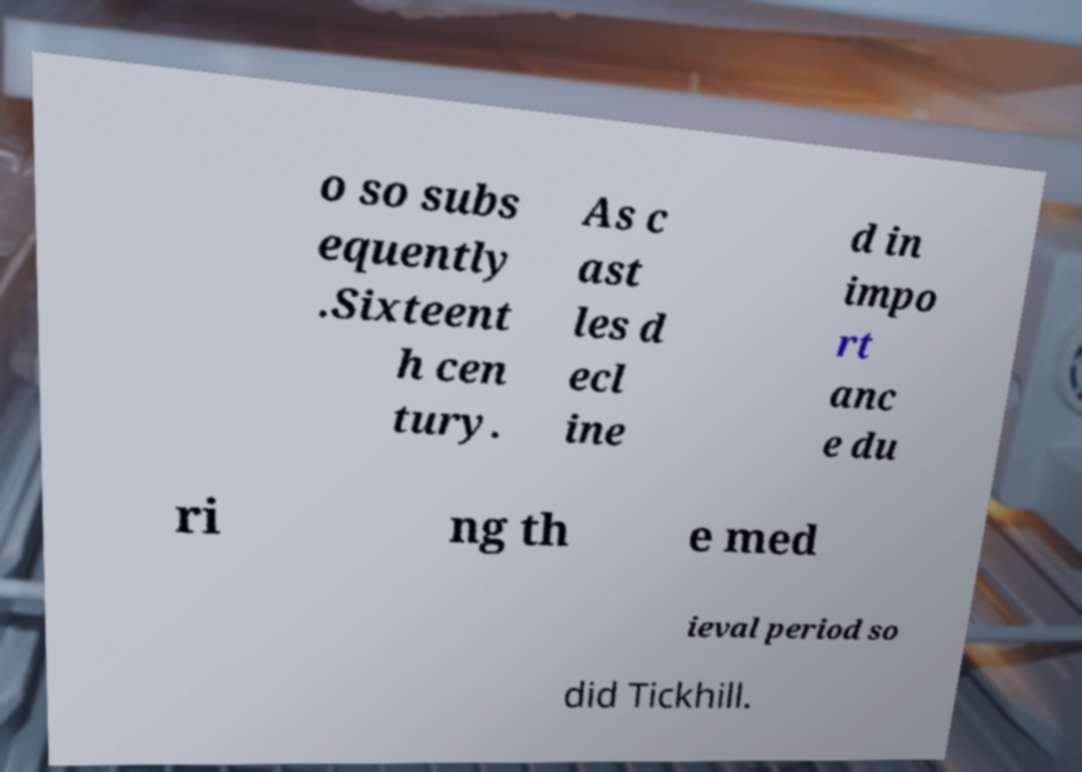Can you accurately transcribe the text from the provided image for me? o so subs equently .Sixteent h cen tury. As c ast les d ecl ine d in impo rt anc e du ri ng th e med ieval period so did Tickhill. 